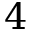<formula> <loc_0><loc_0><loc_500><loc_500>4</formula> 